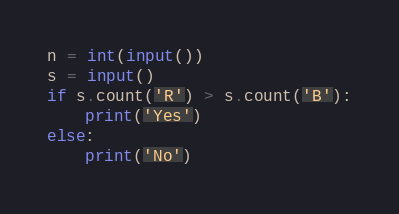Convert code to text. <code><loc_0><loc_0><loc_500><loc_500><_Python_>n = int(input())
s = input()
if s.count('R') > s.count('B'):
    print('Yes')
else:
    print('No')</code> 